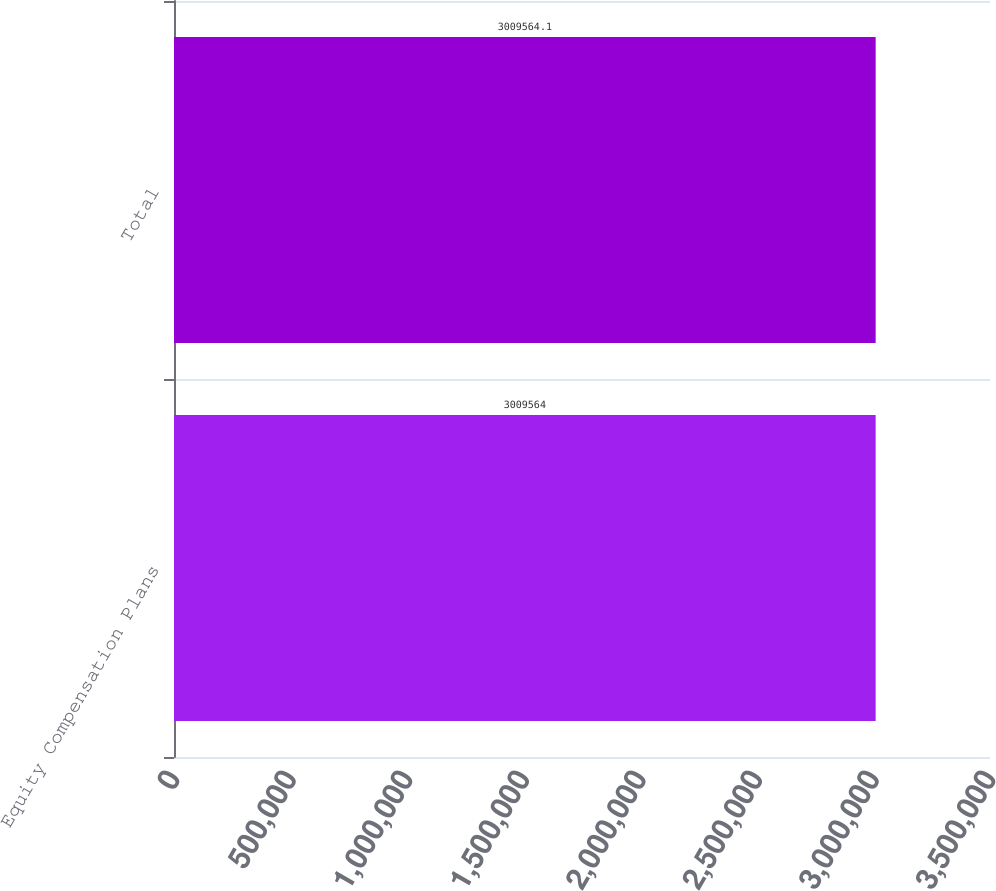<chart> <loc_0><loc_0><loc_500><loc_500><bar_chart><fcel>Equity Compensation Plans<fcel>Total<nl><fcel>3.00956e+06<fcel>3.00956e+06<nl></chart> 